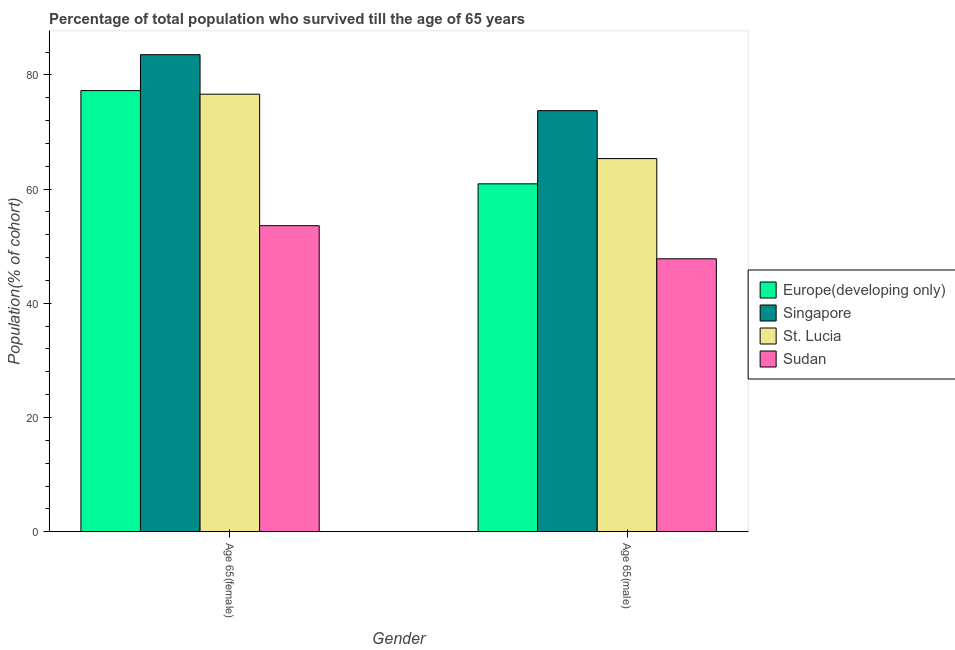How many different coloured bars are there?
Give a very brief answer. 4. How many groups of bars are there?
Ensure brevity in your answer.  2. Are the number of bars per tick equal to the number of legend labels?
Give a very brief answer. Yes. Are the number of bars on each tick of the X-axis equal?
Ensure brevity in your answer.  Yes. How many bars are there on the 1st tick from the right?
Give a very brief answer. 4. What is the label of the 2nd group of bars from the left?
Provide a short and direct response. Age 65(male). What is the percentage of female population who survived till age of 65 in Sudan?
Give a very brief answer. 53.6. Across all countries, what is the maximum percentage of female population who survived till age of 65?
Your response must be concise. 83.55. Across all countries, what is the minimum percentage of male population who survived till age of 65?
Make the answer very short. 47.8. In which country was the percentage of male population who survived till age of 65 maximum?
Make the answer very short. Singapore. In which country was the percentage of male population who survived till age of 65 minimum?
Your answer should be very brief. Sudan. What is the total percentage of female population who survived till age of 65 in the graph?
Provide a short and direct response. 291.02. What is the difference between the percentage of male population who survived till age of 65 in St. Lucia and that in Sudan?
Offer a terse response. 17.55. What is the difference between the percentage of male population who survived till age of 65 in Europe(developing only) and the percentage of female population who survived till age of 65 in Sudan?
Provide a short and direct response. 7.33. What is the average percentage of male population who survived till age of 65 per country?
Ensure brevity in your answer.  61.95. What is the difference between the percentage of female population who survived till age of 65 and percentage of male population who survived till age of 65 in Singapore?
Provide a short and direct response. 9.8. In how many countries, is the percentage of female population who survived till age of 65 greater than 56 %?
Provide a short and direct response. 3. What is the ratio of the percentage of female population who survived till age of 65 in Singapore to that in Europe(developing only)?
Give a very brief answer. 1.08. What does the 1st bar from the left in Age 65(male) represents?
Your answer should be very brief. Europe(developing only). What does the 4th bar from the right in Age 65(female) represents?
Ensure brevity in your answer.  Europe(developing only). Are all the bars in the graph horizontal?
Give a very brief answer. No. How many countries are there in the graph?
Your answer should be compact. 4. Are the values on the major ticks of Y-axis written in scientific E-notation?
Offer a very short reply. No. Where does the legend appear in the graph?
Your answer should be compact. Center right. How many legend labels are there?
Your answer should be very brief. 4. What is the title of the graph?
Provide a succinct answer. Percentage of total population who survived till the age of 65 years. What is the label or title of the Y-axis?
Offer a terse response. Population(% of cohort). What is the Population(% of cohort) of Europe(developing only) in Age 65(female)?
Keep it short and to the point. 77.25. What is the Population(% of cohort) in Singapore in Age 65(female)?
Provide a short and direct response. 83.55. What is the Population(% of cohort) in St. Lucia in Age 65(female)?
Provide a short and direct response. 76.63. What is the Population(% of cohort) of Sudan in Age 65(female)?
Ensure brevity in your answer.  53.6. What is the Population(% of cohort) in Europe(developing only) in Age 65(male)?
Your answer should be very brief. 60.92. What is the Population(% of cohort) in Singapore in Age 65(male)?
Your response must be concise. 73.74. What is the Population(% of cohort) of St. Lucia in Age 65(male)?
Provide a succinct answer. 65.35. What is the Population(% of cohort) in Sudan in Age 65(male)?
Provide a short and direct response. 47.8. Across all Gender, what is the maximum Population(% of cohort) of Europe(developing only)?
Ensure brevity in your answer.  77.25. Across all Gender, what is the maximum Population(% of cohort) in Singapore?
Offer a very short reply. 83.55. Across all Gender, what is the maximum Population(% of cohort) of St. Lucia?
Offer a very short reply. 76.63. Across all Gender, what is the maximum Population(% of cohort) of Sudan?
Your answer should be very brief. 53.6. Across all Gender, what is the minimum Population(% of cohort) of Europe(developing only)?
Offer a very short reply. 60.92. Across all Gender, what is the minimum Population(% of cohort) in Singapore?
Provide a succinct answer. 73.74. Across all Gender, what is the minimum Population(% of cohort) in St. Lucia?
Offer a very short reply. 65.35. Across all Gender, what is the minimum Population(% of cohort) in Sudan?
Keep it short and to the point. 47.8. What is the total Population(% of cohort) of Europe(developing only) in the graph?
Give a very brief answer. 138.18. What is the total Population(% of cohort) of Singapore in the graph?
Ensure brevity in your answer.  157.29. What is the total Population(% of cohort) of St. Lucia in the graph?
Your answer should be compact. 141.97. What is the total Population(% of cohort) of Sudan in the graph?
Your response must be concise. 101.39. What is the difference between the Population(% of cohort) in Europe(developing only) in Age 65(female) and that in Age 65(male)?
Provide a short and direct response. 16.33. What is the difference between the Population(% of cohort) in Singapore in Age 65(female) and that in Age 65(male)?
Provide a short and direct response. 9.8. What is the difference between the Population(% of cohort) of St. Lucia in Age 65(female) and that in Age 65(male)?
Ensure brevity in your answer.  11.28. What is the difference between the Population(% of cohort) of Sudan in Age 65(female) and that in Age 65(male)?
Offer a very short reply. 5.8. What is the difference between the Population(% of cohort) in Europe(developing only) in Age 65(female) and the Population(% of cohort) in Singapore in Age 65(male)?
Your response must be concise. 3.51. What is the difference between the Population(% of cohort) in Europe(developing only) in Age 65(female) and the Population(% of cohort) in St. Lucia in Age 65(male)?
Ensure brevity in your answer.  11.91. What is the difference between the Population(% of cohort) in Europe(developing only) in Age 65(female) and the Population(% of cohort) in Sudan in Age 65(male)?
Your answer should be very brief. 29.46. What is the difference between the Population(% of cohort) of Singapore in Age 65(female) and the Population(% of cohort) of St. Lucia in Age 65(male)?
Give a very brief answer. 18.2. What is the difference between the Population(% of cohort) in Singapore in Age 65(female) and the Population(% of cohort) in Sudan in Age 65(male)?
Provide a succinct answer. 35.75. What is the difference between the Population(% of cohort) of St. Lucia in Age 65(female) and the Population(% of cohort) of Sudan in Age 65(male)?
Provide a short and direct response. 28.83. What is the average Population(% of cohort) in Europe(developing only) per Gender?
Your response must be concise. 69.09. What is the average Population(% of cohort) in Singapore per Gender?
Your response must be concise. 78.64. What is the average Population(% of cohort) of St. Lucia per Gender?
Provide a short and direct response. 70.99. What is the average Population(% of cohort) of Sudan per Gender?
Your response must be concise. 50.7. What is the difference between the Population(% of cohort) in Europe(developing only) and Population(% of cohort) in Singapore in Age 65(female)?
Keep it short and to the point. -6.29. What is the difference between the Population(% of cohort) in Europe(developing only) and Population(% of cohort) in St. Lucia in Age 65(female)?
Your answer should be very brief. 0.63. What is the difference between the Population(% of cohort) in Europe(developing only) and Population(% of cohort) in Sudan in Age 65(female)?
Offer a very short reply. 23.66. What is the difference between the Population(% of cohort) of Singapore and Population(% of cohort) of St. Lucia in Age 65(female)?
Give a very brief answer. 6.92. What is the difference between the Population(% of cohort) in Singapore and Population(% of cohort) in Sudan in Age 65(female)?
Provide a short and direct response. 29.95. What is the difference between the Population(% of cohort) in St. Lucia and Population(% of cohort) in Sudan in Age 65(female)?
Give a very brief answer. 23.03. What is the difference between the Population(% of cohort) of Europe(developing only) and Population(% of cohort) of Singapore in Age 65(male)?
Provide a succinct answer. -12.82. What is the difference between the Population(% of cohort) of Europe(developing only) and Population(% of cohort) of St. Lucia in Age 65(male)?
Provide a short and direct response. -4.42. What is the difference between the Population(% of cohort) in Europe(developing only) and Population(% of cohort) in Sudan in Age 65(male)?
Make the answer very short. 13.13. What is the difference between the Population(% of cohort) of Singapore and Population(% of cohort) of St. Lucia in Age 65(male)?
Your answer should be very brief. 8.39. What is the difference between the Population(% of cohort) of Singapore and Population(% of cohort) of Sudan in Age 65(male)?
Give a very brief answer. 25.95. What is the difference between the Population(% of cohort) in St. Lucia and Population(% of cohort) in Sudan in Age 65(male)?
Provide a succinct answer. 17.55. What is the ratio of the Population(% of cohort) in Europe(developing only) in Age 65(female) to that in Age 65(male)?
Ensure brevity in your answer.  1.27. What is the ratio of the Population(% of cohort) of Singapore in Age 65(female) to that in Age 65(male)?
Offer a very short reply. 1.13. What is the ratio of the Population(% of cohort) in St. Lucia in Age 65(female) to that in Age 65(male)?
Provide a succinct answer. 1.17. What is the ratio of the Population(% of cohort) of Sudan in Age 65(female) to that in Age 65(male)?
Keep it short and to the point. 1.12. What is the difference between the highest and the second highest Population(% of cohort) in Europe(developing only)?
Your response must be concise. 16.33. What is the difference between the highest and the second highest Population(% of cohort) in Singapore?
Provide a succinct answer. 9.8. What is the difference between the highest and the second highest Population(% of cohort) in St. Lucia?
Your answer should be compact. 11.28. What is the difference between the highest and the lowest Population(% of cohort) of Europe(developing only)?
Your answer should be very brief. 16.33. What is the difference between the highest and the lowest Population(% of cohort) of Singapore?
Provide a short and direct response. 9.8. What is the difference between the highest and the lowest Population(% of cohort) of St. Lucia?
Give a very brief answer. 11.28. What is the difference between the highest and the lowest Population(% of cohort) in Sudan?
Ensure brevity in your answer.  5.8. 